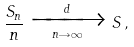Convert formula to latex. <formula><loc_0><loc_0><loc_500><loc_500>\frac { S _ { n } } { n } \xrightarrow [ n \rightarrow \infty ] { d } S \, ,</formula> 